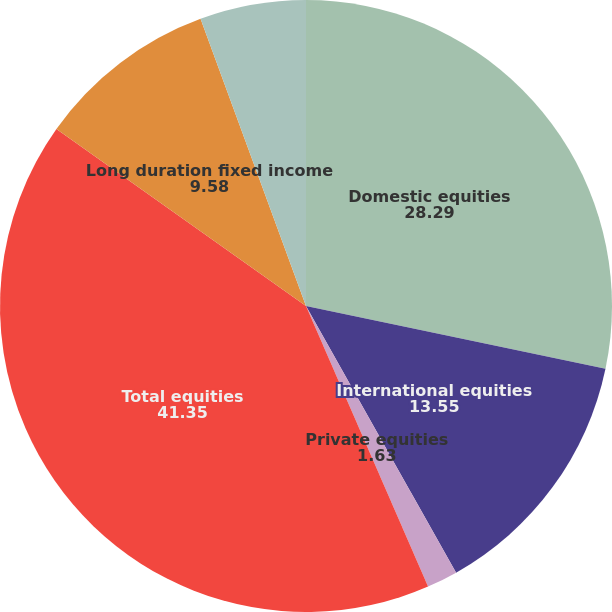Convert chart to OTSL. <chart><loc_0><loc_0><loc_500><loc_500><pie_chart><fcel>Domestic equities<fcel>International equities<fcel>Private equities<fcel>Total equities<fcel>Long duration fixed income<fcel>Other fixed income securities<nl><fcel>28.29%<fcel>13.55%<fcel>1.63%<fcel>41.35%<fcel>9.58%<fcel>5.6%<nl></chart> 